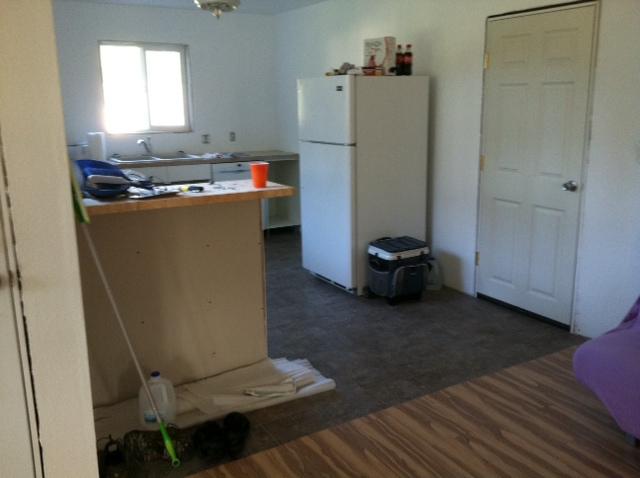What side is the stove on?
Answer briefly. Left. Are there different floorings?
Quick response, please. Yes. What room is this?
Give a very brief answer. Kitchen. Is there an animal there?
Short answer required. No. Is construction work being done?
Concise answer only. Yes. Does this picture represent happiness?
Be succinct. No. Is that a vintage looking refrigerator?
Be succinct. No. How many locks are on the door furthest from the viewer?
Concise answer only. 1. What color is the fridge?
Be succinct. White. How many entrances to rooms are there?
Concise answer only. 1. What is the white thing in the corner of the room?
Write a very short answer. Refrigerator. 